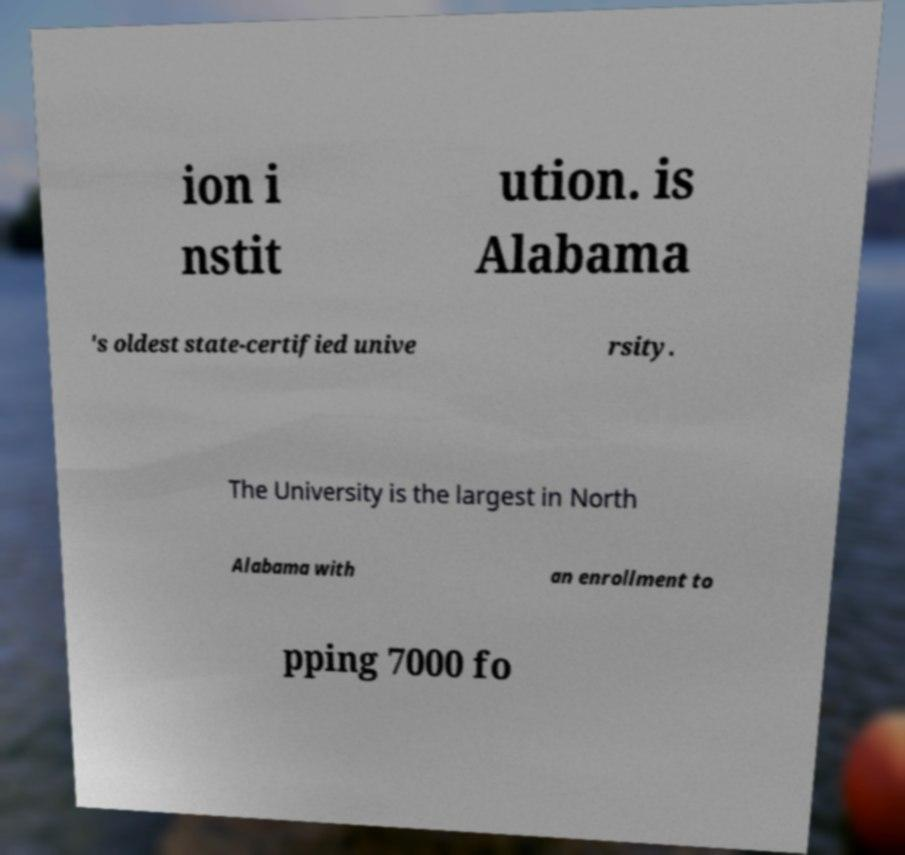Please identify and transcribe the text found in this image. ion i nstit ution. is Alabama 's oldest state-certified unive rsity. The University is the largest in North Alabama with an enrollment to pping 7000 fo 